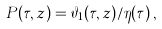Convert formula to latex. <formula><loc_0><loc_0><loc_500><loc_500>P ( \tau , z ) = \vartheta _ { 1 } ( \tau , z ) / \eta ( \tau ) \, ,</formula> 